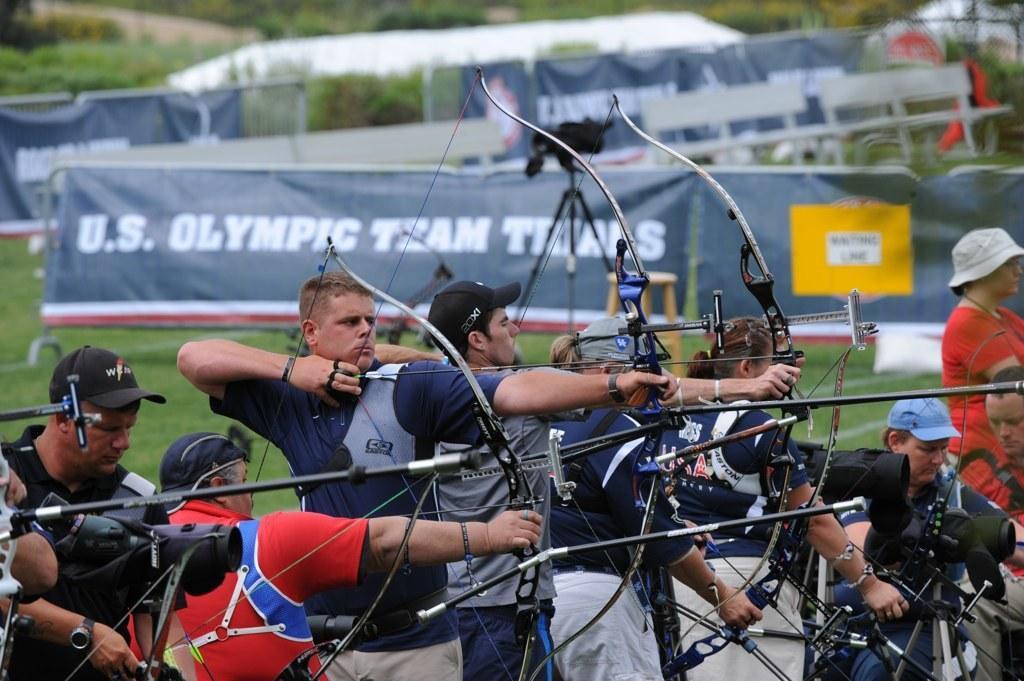Describe this image in one or two sentences. In this picture, there are people playing archery. In the center, there is a man wearing a blue t shirt and holding the bow and a arrow. At the bottom right, there is a person holding something. Towards the right, there is a woman red clothes. In the background there are banners with some text and trees. 